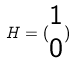<formula> <loc_0><loc_0><loc_500><loc_500>H = ( \begin{matrix} 1 \\ 0 \end{matrix} )</formula> 